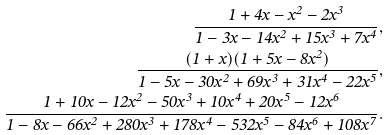Convert formula to latex. <formula><loc_0><loc_0><loc_500><loc_500>\frac { 1 + 4 x - x ^ { 2 } - 2 x ^ { 3 } } { 1 - 3 x - 1 4 x ^ { 2 } + 1 5 x ^ { 3 } + 7 x ^ { 4 } } , \\ \frac { ( 1 + x ) ( 1 + 5 x - 8 x ^ { 2 } ) } { 1 - 5 x - 3 0 x ^ { 2 } + 6 9 x ^ { 3 } + 3 1 x ^ { 4 } - 2 2 x ^ { 5 } } , \\ \frac { 1 + 1 0 x - 1 2 x ^ { 2 } - 5 0 x ^ { 3 } + 1 0 x ^ { 4 } + 2 0 x ^ { 5 } - 1 2 x ^ { 6 } } { 1 - 8 x - 6 6 x ^ { 2 } + 2 8 0 x ^ { 3 } + 1 7 8 x ^ { 4 } - 5 3 2 x ^ { 5 } - 8 4 x ^ { 6 } + 1 0 8 x ^ { 7 } } .</formula> 